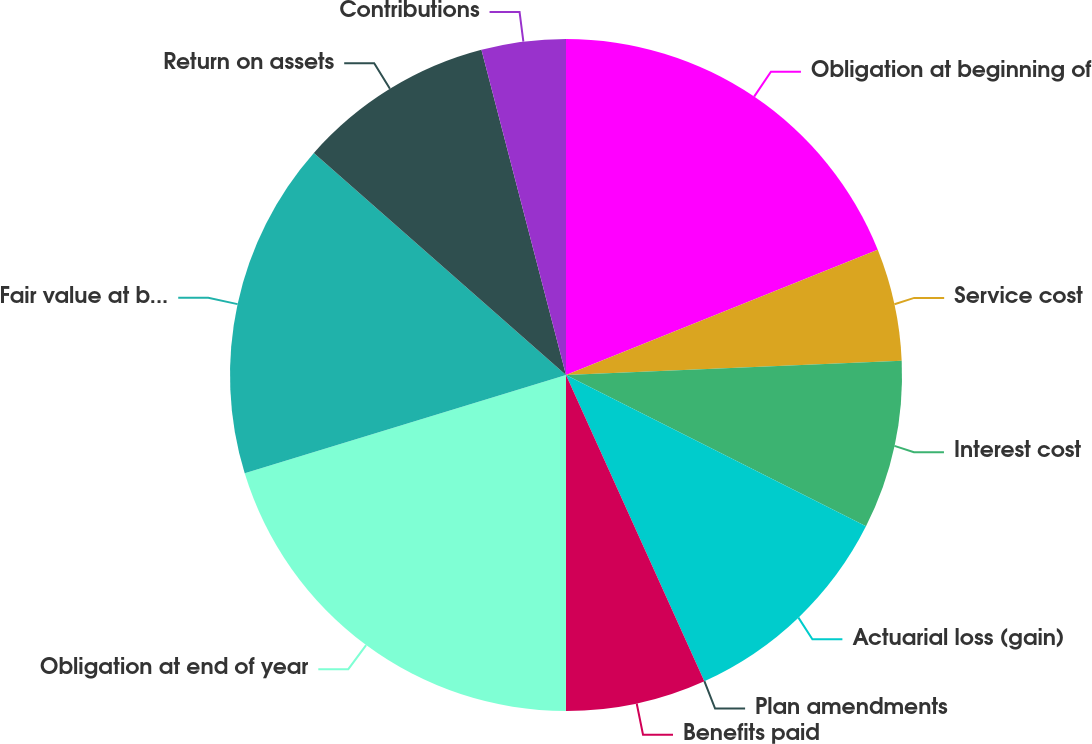Convert chart to OTSL. <chart><loc_0><loc_0><loc_500><loc_500><pie_chart><fcel>Obligation at beginning of<fcel>Service cost<fcel>Interest cost<fcel>Actuarial loss (gain)<fcel>Plan amendments<fcel>Benefits paid<fcel>Obligation at end of year<fcel>Fair value at beginning of<fcel>Return on assets<fcel>Contributions<nl><fcel>18.92%<fcel>5.41%<fcel>8.11%<fcel>10.81%<fcel>0.0%<fcel>6.76%<fcel>20.27%<fcel>16.22%<fcel>9.46%<fcel>4.05%<nl></chart> 